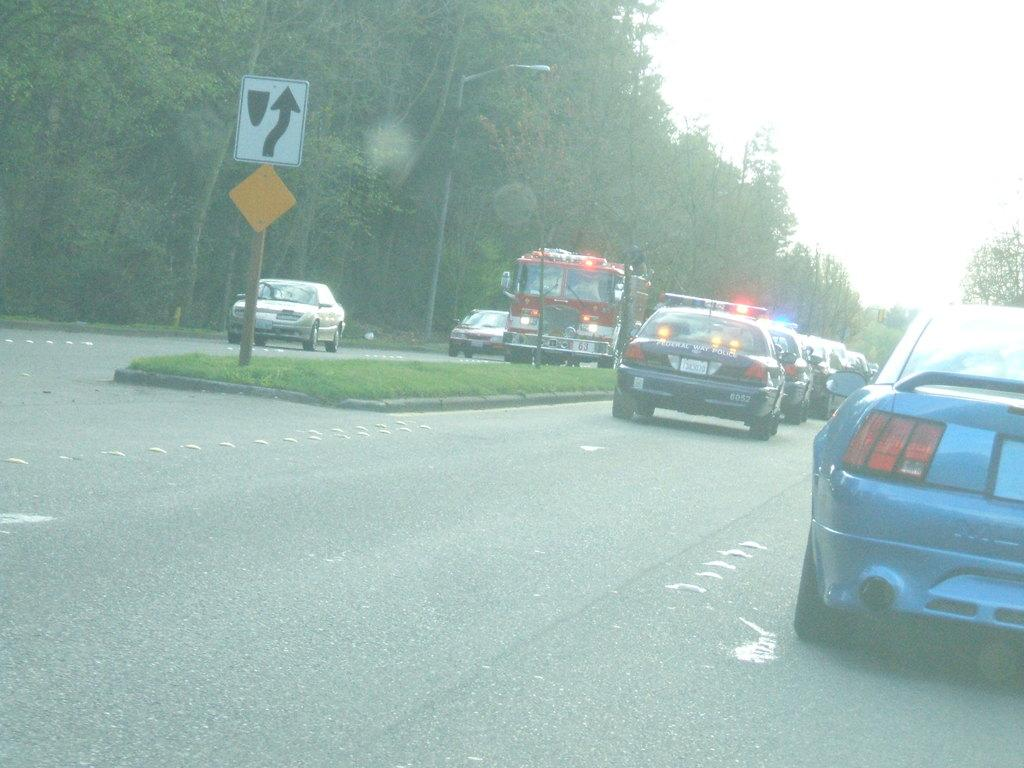What can be seen on the road in the image? There are vehicles on the road in the image. What is visible in the background of the image? There are trees and boards visible in the background of the image. Can you describe the light in the image? There is a light in the image, but its specific purpose or function is not clear. What is visible at the top of the image? The sky is visible at the top of the image. What advice does the goose in the image give to the vehicles on the road? There is no goose present in the image, so it cannot provide any advice to the vehicles on the road. Is there any grass visible in the image? There is no mention of grass in the provided facts, so it is not possible to determine if grass is visible in the image. 